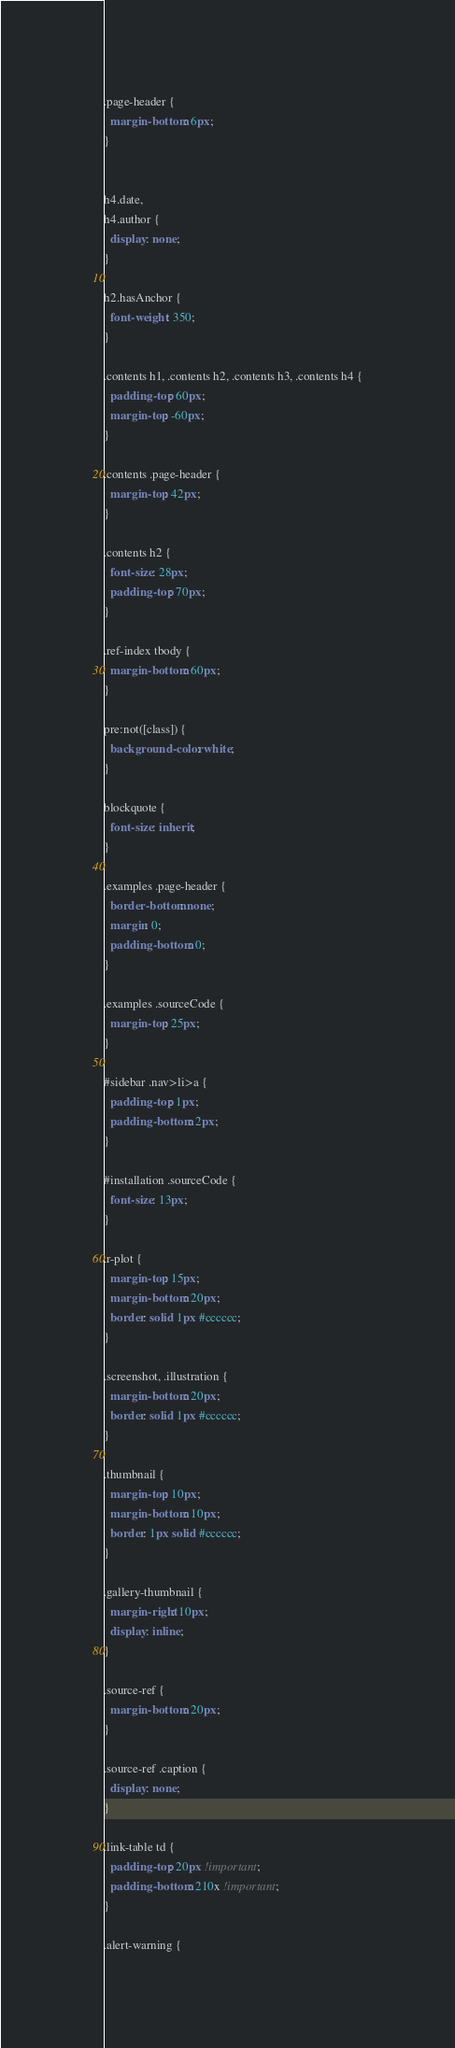<code> <loc_0><loc_0><loc_500><loc_500><_CSS_>
.page-header {
  margin-bottom: 6px;
}


h4.date,
h4.author {
  display: none;
}

h2.hasAnchor {
  font-weight: 350;
}

.contents h1, .contents h2, .contents h3, .contents h4 {
  padding-top: 60px;
  margin-top: -60px;
}

.contents .page-header {
  margin-top: 42px;
}

.contents h2 {
  font-size: 28px;
  padding-top: 70px;
}

.ref-index tbody {
  margin-bottom: 60px;
}

pre:not([class]) {
  background-color: white;
}

blockquote {
  font-size: inherit;
}

.examples .page-header {
  border-bottom: none;
  margin: 0;
  padding-bottom: 0;
}

.examples .sourceCode {
  margin-top: 25px;
}

#sidebar .nav>li>a {
  padding-top: 1px;
  padding-bottom: 2px;
}

#installation .sourceCode {
  font-size: 13px;
}

.r-plot {
  margin-top: 15px;
  margin-bottom: 20px;
  border: solid 1px #cccccc;
}

.screenshot, .illustration {
  margin-bottom: 20px;
  border: solid 1px #cccccc;
}

.thumbnail {
  margin-top: 10px;
  margin-bottom: 10px;
  border: 1px solid #cccccc;
}

.gallery-thumbnail {
  margin-right: 10px;
  display: inline;
}

.source-ref {
  margin-bottom: 20px;
}

.source-ref .caption {
  display: none;
}

.link-table td {
  padding-top: 20px !important;
  padding-bottom: 210x !important;
}

.alert-warning {</code> 